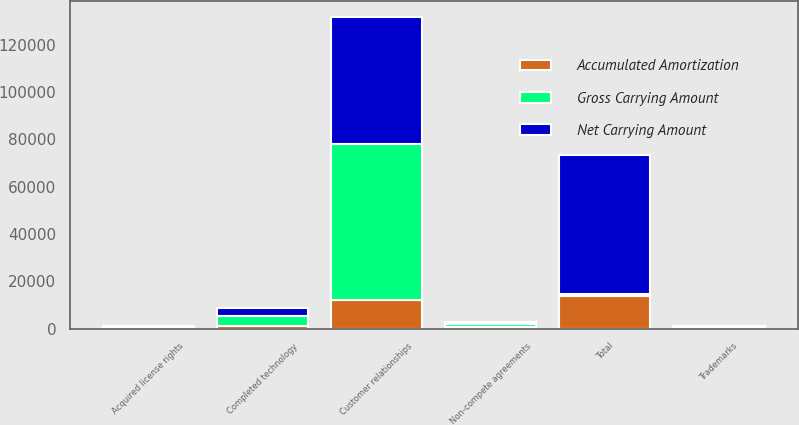Convert chart. <chart><loc_0><loc_0><loc_500><loc_500><stacked_bar_chart><ecel><fcel>Completed technology<fcel>Customer relationships<fcel>Non-compete agreements<fcel>Trademarks<fcel>Acquired license rights<fcel>Total<nl><fcel>Gross Carrying Amount<fcel>4400<fcel>65900<fcel>1300<fcel>500<fcel>490<fcel>863<nl><fcel>Accumulated Amortization<fcel>863<fcel>11970<fcel>674<fcel>5<fcel>395<fcel>13907<nl><fcel>Net Carrying Amount<fcel>3537<fcel>53930<fcel>626<fcel>495<fcel>95<fcel>58683<nl></chart> 